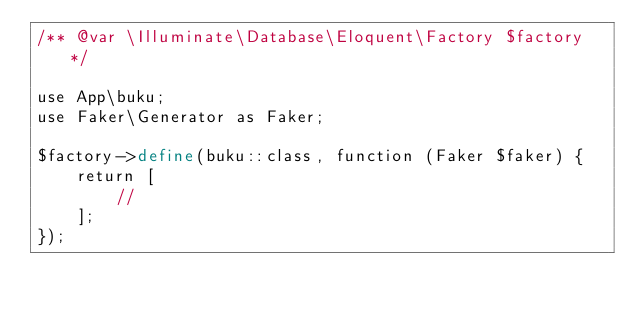Convert code to text. <code><loc_0><loc_0><loc_500><loc_500><_PHP_>/** @var \Illuminate\Database\Eloquent\Factory $factory */

use App\buku;
use Faker\Generator as Faker;

$factory->define(buku::class, function (Faker $faker) {
    return [
        //
    ];
});
</code> 